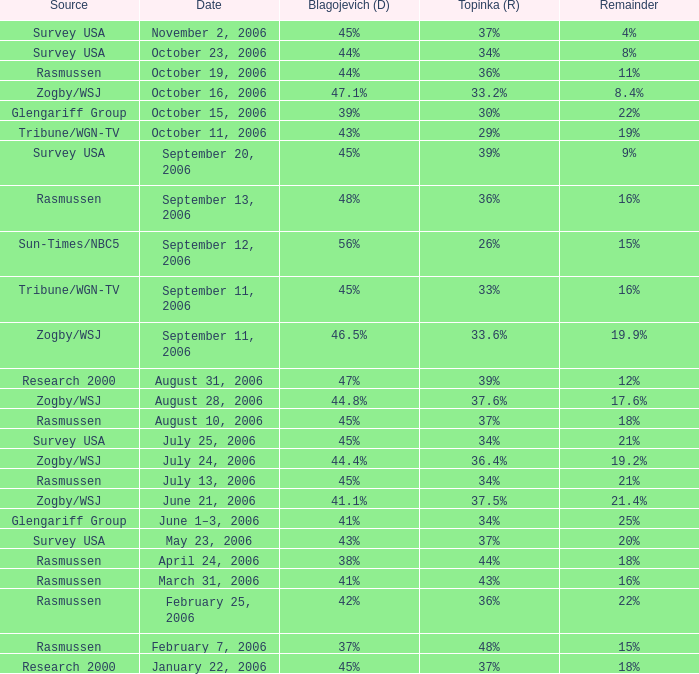Which Blagojevich (D) happened on october 16, 2006? 47.1%. 